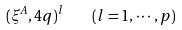<formula> <loc_0><loc_0><loc_500><loc_500>( \xi ^ { A } , 4 q ) ^ { l } \quad ( l = 1 , \cdots , p )</formula> 